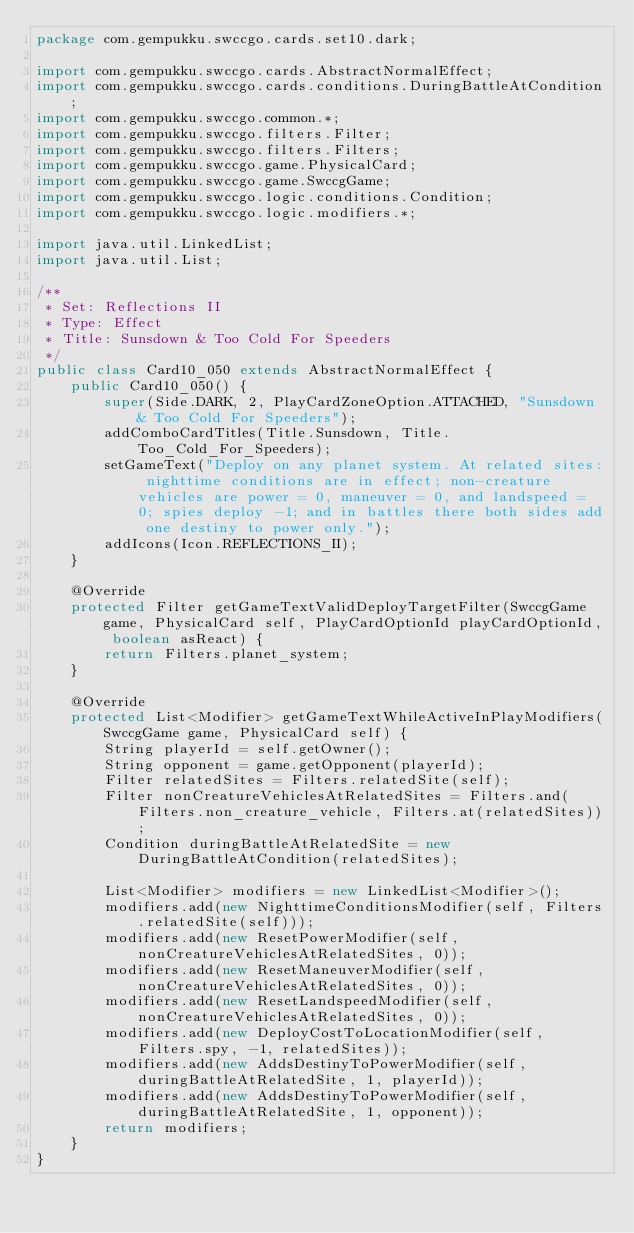<code> <loc_0><loc_0><loc_500><loc_500><_Java_>package com.gempukku.swccgo.cards.set10.dark;

import com.gempukku.swccgo.cards.AbstractNormalEffect;
import com.gempukku.swccgo.cards.conditions.DuringBattleAtCondition;
import com.gempukku.swccgo.common.*;
import com.gempukku.swccgo.filters.Filter;
import com.gempukku.swccgo.filters.Filters;
import com.gempukku.swccgo.game.PhysicalCard;
import com.gempukku.swccgo.game.SwccgGame;
import com.gempukku.swccgo.logic.conditions.Condition;
import com.gempukku.swccgo.logic.modifiers.*;

import java.util.LinkedList;
import java.util.List;

/**
 * Set: Reflections II
 * Type: Effect
 * Title: Sunsdown & Too Cold For Speeders
 */
public class Card10_050 extends AbstractNormalEffect {
    public Card10_050() {
        super(Side.DARK, 2, PlayCardZoneOption.ATTACHED, "Sunsdown & Too Cold For Speeders");
        addComboCardTitles(Title.Sunsdown, Title.Too_Cold_For_Speeders);
        setGameText("Deploy on any planet system. At related sites: nighttime conditions are in effect; non-creature vehicles are power = 0, maneuver = 0, and landspeed = 0; spies deploy -1; and in battles there both sides add one destiny to power only.");
        addIcons(Icon.REFLECTIONS_II);
    }

    @Override
    protected Filter getGameTextValidDeployTargetFilter(SwccgGame game, PhysicalCard self, PlayCardOptionId playCardOptionId, boolean asReact) {
        return Filters.planet_system;
    }

    @Override
    protected List<Modifier> getGameTextWhileActiveInPlayModifiers(SwccgGame game, PhysicalCard self) {
        String playerId = self.getOwner();
        String opponent = game.getOpponent(playerId);
        Filter relatedSites = Filters.relatedSite(self);
        Filter nonCreatureVehiclesAtRelatedSites = Filters.and(Filters.non_creature_vehicle, Filters.at(relatedSites));
        Condition duringBattleAtRelatedSite = new DuringBattleAtCondition(relatedSites);

        List<Modifier> modifiers = new LinkedList<Modifier>();
        modifiers.add(new NighttimeConditionsModifier(self, Filters.relatedSite(self)));
        modifiers.add(new ResetPowerModifier(self, nonCreatureVehiclesAtRelatedSites, 0));
        modifiers.add(new ResetManeuverModifier(self, nonCreatureVehiclesAtRelatedSites, 0));
        modifiers.add(new ResetLandspeedModifier(self, nonCreatureVehiclesAtRelatedSites, 0));
        modifiers.add(new DeployCostToLocationModifier(self, Filters.spy, -1, relatedSites));
        modifiers.add(new AddsDestinyToPowerModifier(self, duringBattleAtRelatedSite, 1, playerId));
        modifiers.add(new AddsDestinyToPowerModifier(self, duringBattleAtRelatedSite, 1, opponent));
        return modifiers;
    }
}</code> 